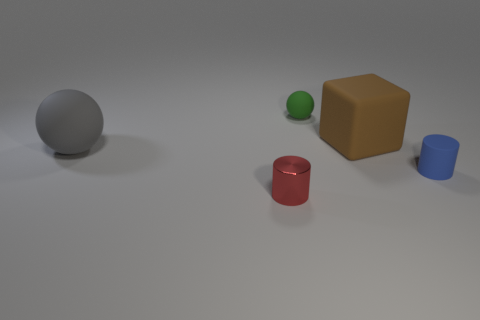Add 4 red metal cylinders. How many objects exist? 9 Subtract all cubes. How many objects are left? 4 Add 2 green things. How many green things exist? 3 Subtract 0 red spheres. How many objects are left? 5 Subtract all small cyan metal blocks. Subtract all blue cylinders. How many objects are left? 4 Add 5 large rubber balls. How many large rubber balls are left? 6 